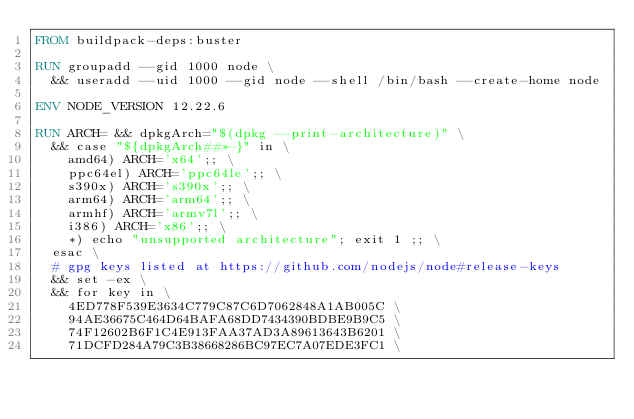<code> <loc_0><loc_0><loc_500><loc_500><_Dockerfile_>FROM buildpack-deps:buster

RUN groupadd --gid 1000 node \
  && useradd --uid 1000 --gid node --shell /bin/bash --create-home node

ENV NODE_VERSION 12.22.6

RUN ARCH= && dpkgArch="$(dpkg --print-architecture)" \
  && case "${dpkgArch##*-}" in \
    amd64) ARCH='x64';; \
    ppc64el) ARCH='ppc64le';; \
    s390x) ARCH='s390x';; \
    arm64) ARCH='arm64';; \
    armhf) ARCH='armv7l';; \
    i386) ARCH='x86';; \
    *) echo "unsupported architecture"; exit 1 ;; \
  esac \
  # gpg keys listed at https://github.com/nodejs/node#release-keys
  && set -ex \
  && for key in \
    4ED778F539E3634C779C87C6D7062848A1AB005C \
    94AE36675C464D64BAFA68DD7434390BDBE9B9C5 \
    74F12602B6F1C4E913FAA37AD3A89613643B6201 \
    71DCFD284A79C3B38668286BC97EC7A07EDE3FC1 \</code> 